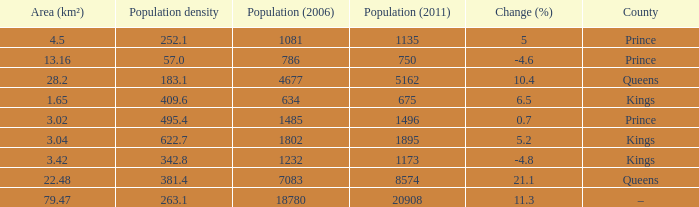What was the Area (km²) when the Population (2011) was 8574, and the Population density was larger than 381.4? None. 